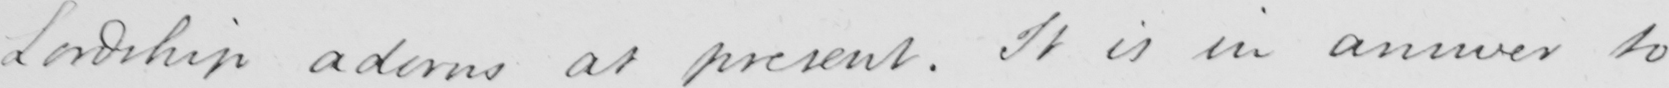Can you read and transcribe this handwriting? Lordship adorns at present . It is in answer to 